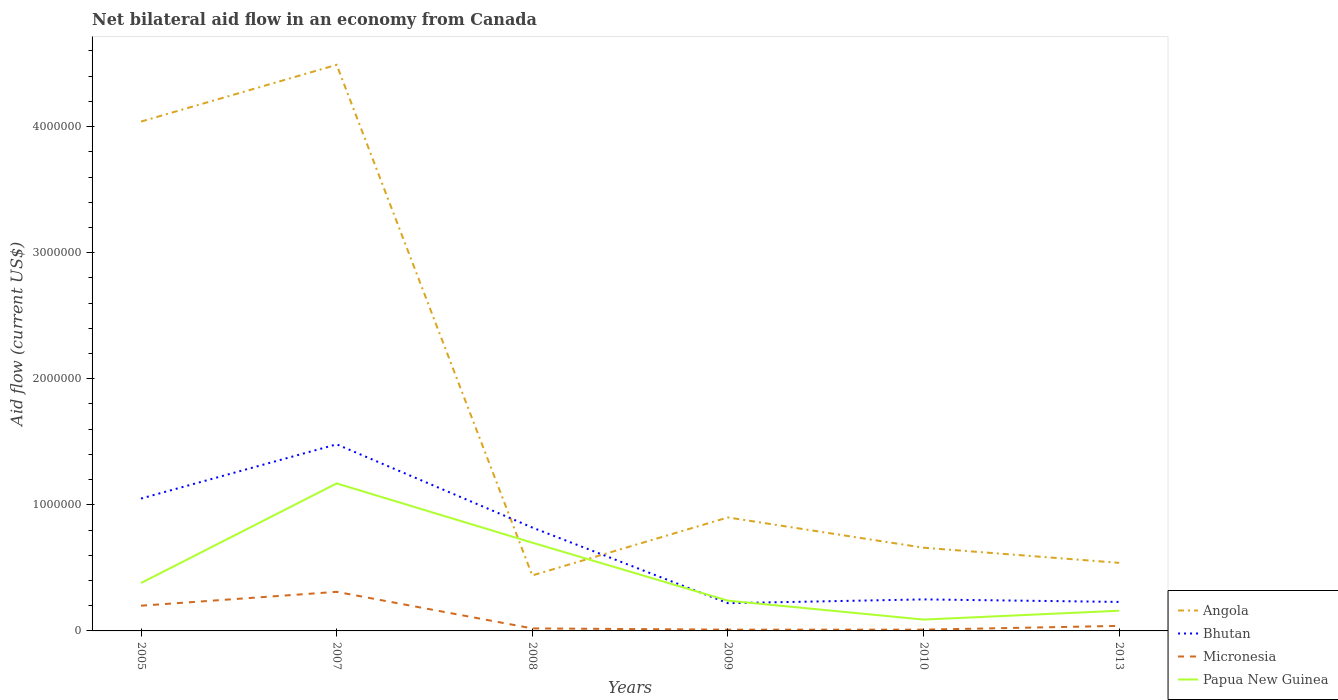In which year was the net bilateral aid flow in Angola maximum?
Your answer should be compact. 2008. What is the total net bilateral aid flow in Bhutan in the graph?
Ensure brevity in your answer.  5.70e+05. What is the difference between the highest and the second highest net bilateral aid flow in Micronesia?
Your response must be concise. 3.00e+05. What is the difference between two consecutive major ticks on the Y-axis?
Your response must be concise. 1.00e+06. Are the values on the major ticks of Y-axis written in scientific E-notation?
Give a very brief answer. No. How many legend labels are there?
Your answer should be very brief. 4. How are the legend labels stacked?
Make the answer very short. Vertical. What is the title of the graph?
Your answer should be compact. Net bilateral aid flow in an economy from Canada. What is the label or title of the Y-axis?
Your answer should be compact. Aid flow (current US$). What is the Aid flow (current US$) of Angola in 2005?
Offer a very short reply. 4.04e+06. What is the Aid flow (current US$) of Bhutan in 2005?
Offer a terse response. 1.05e+06. What is the Aid flow (current US$) in Micronesia in 2005?
Offer a terse response. 2.00e+05. What is the Aid flow (current US$) of Papua New Guinea in 2005?
Offer a terse response. 3.80e+05. What is the Aid flow (current US$) of Angola in 2007?
Make the answer very short. 4.49e+06. What is the Aid flow (current US$) of Bhutan in 2007?
Provide a succinct answer. 1.48e+06. What is the Aid flow (current US$) in Micronesia in 2007?
Offer a very short reply. 3.10e+05. What is the Aid flow (current US$) in Papua New Guinea in 2007?
Provide a short and direct response. 1.17e+06. What is the Aid flow (current US$) in Bhutan in 2008?
Your answer should be compact. 8.20e+05. What is the Aid flow (current US$) in Micronesia in 2008?
Your response must be concise. 2.00e+04. What is the Aid flow (current US$) in Bhutan in 2009?
Make the answer very short. 2.20e+05. What is the Aid flow (current US$) in Micronesia in 2009?
Make the answer very short. 10000. What is the Aid flow (current US$) of Bhutan in 2010?
Your answer should be compact. 2.50e+05. What is the Aid flow (current US$) of Micronesia in 2010?
Give a very brief answer. 10000. What is the Aid flow (current US$) of Papua New Guinea in 2010?
Ensure brevity in your answer.  9.00e+04. What is the Aid flow (current US$) of Angola in 2013?
Give a very brief answer. 5.40e+05. What is the Aid flow (current US$) of Micronesia in 2013?
Ensure brevity in your answer.  4.00e+04. Across all years, what is the maximum Aid flow (current US$) of Angola?
Give a very brief answer. 4.49e+06. Across all years, what is the maximum Aid flow (current US$) of Bhutan?
Provide a short and direct response. 1.48e+06. Across all years, what is the maximum Aid flow (current US$) of Micronesia?
Your response must be concise. 3.10e+05. Across all years, what is the maximum Aid flow (current US$) in Papua New Guinea?
Offer a very short reply. 1.17e+06. Across all years, what is the minimum Aid flow (current US$) of Bhutan?
Your answer should be compact. 2.20e+05. Across all years, what is the minimum Aid flow (current US$) in Micronesia?
Provide a succinct answer. 10000. What is the total Aid flow (current US$) of Angola in the graph?
Give a very brief answer. 1.11e+07. What is the total Aid flow (current US$) in Bhutan in the graph?
Provide a short and direct response. 4.05e+06. What is the total Aid flow (current US$) of Micronesia in the graph?
Give a very brief answer. 5.90e+05. What is the total Aid flow (current US$) in Papua New Guinea in the graph?
Provide a short and direct response. 2.74e+06. What is the difference between the Aid flow (current US$) in Angola in 2005 and that in 2007?
Your answer should be compact. -4.50e+05. What is the difference between the Aid flow (current US$) in Bhutan in 2005 and that in 2007?
Keep it short and to the point. -4.30e+05. What is the difference between the Aid flow (current US$) in Papua New Guinea in 2005 and that in 2007?
Make the answer very short. -7.90e+05. What is the difference between the Aid flow (current US$) in Angola in 2005 and that in 2008?
Your answer should be compact. 3.60e+06. What is the difference between the Aid flow (current US$) of Bhutan in 2005 and that in 2008?
Give a very brief answer. 2.30e+05. What is the difference between the Aid flow (current US$) in Papua New Guinea in 2005 and that in 2008?
Your answer should be very brief. -3.20e+05. What is the difference between the Aid flow (current US$) in Angola in 2005 and that in 2009?
Your answer should be compact. 3.14e+06. What is the difference between the Aid flow (current US$) in Bhutan in 2005 and that in 2009?
Offer a terse response. 8.30e+05. What is the difference between the Aid flow (current US$) in Micronesia in 2005 and that in 2009?
Keep it short and to the point. 1.90e+05. What is the difference between the Aid flow (current US$) in Angola in 2005 and that in 2010?
Keep it short and to the point. 3.38e+06. What is the difference between the Aid flow (current US$) of Bhutan in 2005 and that in 2010?
Make the answer very short. 8.00e+05. What is the difference between the Aid flow (current US$) of Papua New Guinea in 2005 and that in 2010?
Offer a terse response. 2.90e+05. What is the difference between the Aid flow (current US$) in Angola in 2005 and that in 2013?
Provide a succinct answer. 3.50e+06. What is the difference between the Aid flow (current US$) in Bhutan in 2005 and that in 2013?
Provide a succinct answer. 8.20e+05. What is the difference between the Aid flow (current US$) of Micronesia in 2005 and that in 2013?
Provide a short and direct response. 1.60e+05. What is the difference between the Aid flow (current US$) in Papua New Guinea in 2005 and that in 2013?
Your response must be concise. 2.20e+05. What is the difference between the Aid flow (current US$) in Angola in 2007 and that in 2008?
Your answer should be compact. 4.05e+06. What is the difference between the Aid flow (current US$) of Papua New Guinea in 2007 and that in 2008?
Offer a terse response. 4.70e+05. What is the difference between the Aid flow (current US$) in Angola in 2007 and that in 2009?
Your response must be concise. 3.59e+06. What is the difference between the Aid flow (current US$) in Bhutan in 2007 and that in 2009?
Offer a terse response. 1.26e+06. What is the difference between the Aid flow (current US$) in Micronesia in 2007 and that in 2009?
Give a very brief answer. 3.00e+05. What is the difference between the Aid flow (current US$) of Papua New Guinea in 2007 and that in 2009?
Provide a short and direct response. 9.30e+05. What is the difference between the Aid flow (current US$) in Angola in 2007 and that in 2010?
Offer a very short reply. 3.83e+06. What is the difference between the Aid flow (current US$) in Bhutan in 2007 and that in 2010?
Provide a short and direct response. 1.23e+06. What is the difference between the Aid flow (current US$) of Micronesia in 2007 and that in 2010?
Make the answer very short. 3.00e+05. What is the difference between the Aid flow (current US$) of Papua New Guinea in 2007 and that in 2010?
Your response must be concise. 1.08e+06. What is the difference between the Aid flow (current US$) in Angola in 2007 and that in 2013?
Keep it short and to the point. 3.95e+06. What is the difference between the Aid flow (current US$) in Bhutan in 2007 and that in 2013?
Make the answer very short. 1.25e+06. What is the difference between the Aid flow (current US$) in Micronesia in 2007 and that in 2013?
Provide a short and direct response. 2.70e+05. What is the difference between the Aid flow (current US$) of Papua New Guinea in 2007 and that in 2013?
Offer a terse response. 1.01e+06. What is the difference between the Aid flow (current US$) of Angola in 2008 and that in 2009?
Offer a very short reply. -4.60e+05. What is the difference between the Aid flow (current US$) in Papua New Guinea in 2008 and that in 2009?
Provide a short and direct response. 4.60e+05. What is the difference between the Aid flow (current US$) in Bhutan in 2008 and that in 2010?
Offer a terse response. 5.70e+05. What is the difference between the Aid flow (current US$) in Papua New Guinea in 2008 and that in 2010?
Provide a succinct answer. 6.10e+05. What is the difference between the Aid flow (current US$) in Bhutan in 2008 and that in 2013?
Keep it short and to the point. 5.90e+05. What is the difference between the Aid flow (current US$) of Micronesia in 2008 and that in 2013?
Offer a terse response. -2.00e+04. What is the difference between the Aid flow (current US$) in Papua New Guinea in 2008 and that in 2013?
Provide a succinct answer. 5.40e+05. What is the difference between the Aid flow (current US$) in Angola in 2009 and that in 2010?
Your answer should be compact. 2.40e+05. What is the difference between the Aid flow (current US$) of Micronesia in 2009 and that in 2010?
Provide a short and direct response. 0. What is the difference between the Aid flow (current US$) in Papua New Guinea in 2009 and that in 2010?
Ensure brevity in your answer.  1.50e+05. What is the difference between the Aid flow (current US$) in Angola in 2009 and that in 2013?
Your answer should be compact. 3.60e+05. What is the difference between the Aid flow (current US$) of Micronesia in 2009 and that in 2013?
Provide a short and direct response. -3.00e+04. What is the difference between the Aid flow (current US$) of Papua New Guinea in 2009 and that in 2013?
Your answer should be compact. 8.00e+04. What is the difference between the Aid flow (current US$) in Micronesia in 2010 and that in 2013?
Your answer should be compact. -3.00e+04. What is the difference between the Aid flow (current US$) in Papua New Guinea in 2010 and that in 2013?
Make the answer very short. -7.00e+04. What is the difference between the Aid flow (current US$) of Angola in 2005 and the Aid flow (current US$) of Bhutan in 2007?
Provide a succinct answer. 2.56e+06. What is the difference between the Aid flow (current US$) in Angola in 2005 and the Aid flow (current US$) in Micronesia in 2007?
Your response must be concise. 3.73e+06. What is the difference between the Aid flow (current US$) in Angola in 2005 and the Aid flow (current US$) in Papua New Guinea in 2007?
Your answer should be very brief. 2.87e+06. What is the difference between the Aid flow (current US$) of Bhutan in 2005 and the Aid flow (current US$) of Micronesia in 2007?
Keep it short and to the point. 7.40e+05. What is the difference between the Aid flow (current US$) in Micronesia in 2005 and the Aid flow (current US$) in Papua New Guinea in 2007?
Provide a short and direct response. -9.70e+05. What is the difference between the Aid flow (current US$) of Angola in 2005 and the Aid flow (current US$) of Bhutan in 2008?
Your response must be concise. 3.22e+06. What is the difference between the Aid flow (current US$) of Angola in 2005 and the Aid flow (current US$) of Micronesia in 2008?
Give a very brief answer. 4.02e+06. What is the difference between the Aid flow (current US$) of Angola in 2005 and the Aid flow (current US$) of Papua New Guinea in 2008?
Make the answer very short. 3.34e+06. What is the difference between the Aid flow (current US$) of Bhutan in 2005 and the Aid flow (current US$) of Micronesia in 2008?
Your response must be concise. 1.03e+06. What is the difference between the Aid flow (current US$) of Micronesia in 2005 and the Aid flow (current US$) of Papua New Guinea in 2008?
Give a very brief answer. -5.00e+05. What is the difference between the Aid flow (current US$) of Angola in 2005 and the Aid flow (current US$) of Bhutan in 2009?
Your response must be concise. 3.82e+06. What is the difference between the Aid flow (current US$) of Angola in 2005 and the Aid flow (current US$) of Micronesia in 2009?
Offer a very short reply. 4.03e+06. What is the difference between the Aid flow (current US$) in Angola in 2005 and the Aid flow (current US$) in Papua New Guinea in 2009?
Give a very brief answer. 3.80e+06. What is the difference between the Aid flow (current US$) of Bhutan in 2005 and the Aid flow (current US$) of Micronesia in 2009?
Your answer should be very brief. 1.04e+06. What is the difference between the Aid flow (current US$) of Bhutan in 2005 and the Aid flow (current US$) of Papua New Guinea in 2009?
Your response must be concise. 8.10e+05. What is the difference between the Aid flow (current US$) in Micronesia in 2005 and the Aid flow (current US$) in Papua New Guinea in 2009?
Keep it short and to the point. -4.00e+04. What is the difference between the Aid flow (current US$) in Angola in 2005 and the Aid flow (current US$) in Bhutan in 2010?
Keep it short and to the point. 3.79e+06. What is the difference between the Aid flow (current US$) in Angola in 2005 and the Aid flow (current US$) in Micronesia in 2010?
Provide a short and direct response. 4.03e+06. What is the difference between the Aid flow (current US$) of Angola in 2005 and the Aid flow (current US$) of Papua New Guinea in 2010?
Provide a short and direct response. 3.95e+06. What is the difference between the Aid flow (current US$) of Bhutan in 2005 and the Aid flow (current US$) of Micronesia in 2010?
Provide a succinct answer. 1.04e+06. What is the difference between the Aid flow (current US$) in Bhutan in 2005 and the Aid flow (current US$) in Papua New Guinea in 2010?
Your answer should be compact. 9.60e+05. What is the difference between the Aid flow (current US$) in Micronesia in 2005 and the Aid flow (current US$) in Papua New Guinea in 2010?
Keep it short and to the point. 1.10e+05. What is the difference between the Aid flow (current US$) in Angola in 2005 and the Aid flow (current US$) in Bhutan in 2013?
Give a very brief answer. 3.81e+06. What is the difference between the Aid flow (current US$) in Angola in 2005 and the Aid flow (current US$) in Micronesia in 2013?
Your response must be concise. 4.00e+06. What is the difference between the Aid flow (current US$) of Angola in 2005 and the Aid flow (current US$) of Papua New Guinea in 2013?
Give a very brief answer. 3.88e+06. What is the difference between the Aid flow (current US$) in Bhutan in 2005 and the Aid flow (current US$) in Micronesia in 2013?
Your answer should be very brief. 1.01e+06. What is the difference between the Aid flow (current US$) in Bhutan in 2005 and the Aid flow (current US$) in Papua New Guinea in 2013?
Your answer should be compact. 8.90e+05. What is the difference between the Aid flow (current US$) in Micronesia in 2005 and the Aid flow (current US$) in Papua New Guinea in 2013?
Your response must be concise. 4.00e+04. What is the difference between the Aid flow (current US$) in Angola in 2007 and the Aid flow (current US$) in Bhutan in 2008?
Provide a succinct answer. 3.67e+06. What is the difference between the Aid flow (current US$) of Angola in 2007 and the Aid flow (current US$) of Micronesia in 2008?
Your response must be concise. 4.47e+06. What is the difference between the Aid flow (current US$) in Angola in 2007 and the Aid flow (current US$) in Papua New Guinea in 2008?
Provide a short and direct response. 3.79e+06. What is the difference between the Aid flow (current US$) of Bhutan in 2007 and the Aid flow (current US$) of Micronesia in 2008?
Make the answer very short. 1.46e+06. What is the difference between the Aid flow (current US$) in Bhutan in 2007 and the Aid flow (current US$) in Papua New Guinea in 2008?
Provide a short and direct response. 7.80e+05. What is the difference between the Aid flow (current US$) of Micronesia in 2007 and the Aid flow (current US$) of Papua New Guinea in 2008?
Give a very brief answer. -3.90e+05. What is the difference between the Aid flow (current US$) in Angola in 2007 and the Aid flow (current US$) in Bhutan in 2009?
Offer a terse response. 4.27e+06. What is the difference between the Aid flow (current US$) in Angola in 2007 and the Aid flow (current US$) in Micronesia in 2009?
Offer a very short reply. 4.48e+06. What is the difference between the Aid flow (current US$) in Angola in 2007 and the Aid flow (current US$) in Papua New Guinea in 2009?
Keep it short and to the point. 4.25e+06. What is the difference between the Aid flow (current US$) in Bhutan in 2007 and the Aid flow (current US$) in Micronesia in 2009?
Provide a succinct answer. 1.47e+06. What is the difference between the Aid flow (current US$) in Bhutan in 2007 and the Aid flow (current US$) in Papua New Guinea in 2009?
Offer a very short reply. 1.24e+06. What is the difference between the Aid flow (current US$) in Angola in 2007 and the Aid flow (current US$) in Bhutan in 2010?
Provide a succinct answer. 4.24e+06. What is the difference between the Aid flow (current US$) of Angola in 2007 and the Aid flow (current US$) of Micronesia in 2010?
Ensure brevity in your answer.  4.48e+06. What is the difference between the Aid flow (current US$) in Angola in 2007 and the Aid flow (current US$) in Papua New Guinea in 2010?
Give a very brief answer. 4.40e+06. What is the difference between the Aid flow (current US$) in Bhutan in 2007 and the Aid flow (current US$) in Micronesia in 2010?
Your answer should be very brief. 1.47e+06. What is the difference between the Aid flow (current US$) in Bhutan in 2007 and the Aid flow (current US$) in Papua New Guinea in 2010?
Your response must be concise. 1.39e+06. What is the difference between the Aid flow (current US$) in Angola in 2007 and the Aid flow (current US$) in Bhutan in 2013?
Ensure brevity in your answer.  4.26e+06. What is the difference between the Aid flow (current US$) of Angola in 2007 and the Aid flow (current US$) of Micronesia in 2013?
Provide a succinct answer. 4.45e+06. What is the difference between the Aid flow (current US$) of Angola in 2007 and the Aid flow (current US$) of Papua New Guinea in 2013?
Provide a succinct answer. 4.33e+06. What is the difference between the Aid flow (current US$) in Bhutan in 2007 and the Aid flow (current US$) in Micronesia in 2013?
Offer a very short reply. 1.44e+06. What is the difference between the Aid flow (current US$) of Bhutan in 2007 and the Aid flow (current US$) of Papua New Guinea in 2013?
Make the answer very short. 1.32e+06. What is the difference between the Aid flow (current US$) in Angola in 2008 and the Aid flow (current US$) in Papua New Guinea in 2009?
Ensure brevity in your answer.  2.00e+05. What is the difference between the Aid flow (current US$) of Bhutan in 2008 and the Aid flow (current US$) of Micronesia in 2009?
Keep it short and to the point. 8.10e+05. What is the difference between the Aid flow (current US$) in Bhutan in 2008 and the Aid flow (current US$) in Papua New Guinea in 2009?
Make the answer very short. 5.80e+05. What is the difference between the Aid flow (current US$) in Micronesia in 2008 and the Aid flow (current US$) in Papua New Guinea in 2009?
Your response must be concise. -2.20e+05. What is the difference between the Aid flow (current US$) of Angola in 2008 and the Aid flow (current US$) of Bhutan in 2010?
Your answer should be very brief. 1.90e+05. What is the difference between the Aid flow (current US$) of Angola in 2008 and the Aid flow (current US$) of Micronesia in 2010?
Make the answer very short. 4.30e+05. What is the difference between the Aid flow (current US$) of Angola in 2008 and the Aid flow (current US$) of Papua New Guinea in 2010?
Provide a short and direct response. 3.50e+05. What is the difference between the Aid flow (current US$) in Bhutan in 2008 and the Aid flow (current US$) in Micronesia in 2010?
Offer a very short reply. 8.10e+05. What is the difference between the Aid flow (current US$) of Bhutan in 2008 and the Aid flow (current US$) of Papua New Guinea in 2010?
Your response must be concise. 7.30e+05. What is the difference between the Aid flow (current US$) of Angola in 2008 and the Aid flow (current US$) of Micronesia in 2013?
Keep it short and to the point. 4.00e+05. What is the difference between the Aid flow (current US$) in Bhutan in 2008 and the Aid flow (current US$) in Micronesia in 2013?
Give a very brief answer. 7.80e+05. What is the difference between the Aid flow (current US$) in Angola in 2009 and the Aid flow (current US$) in Bhutan in 2010?
Your answer should be very brief. 6.50e+05. What is the difference between the Aid flow (current US$) in Angola in 2009 and the Aid flow (current US$) in Micronesia in 2010?
Provide a short and direct response. 8.90e+05. What is the difference between the Aid flow (current US$) of Angola in 2009 and the Aid flow (current US$) of Papua New Guinea in 2010?
Keep it short and to the point. 8.10e+05. What is the difference between the Aid flow (current US$) in Micronesia in 2009 and the Aid flow (current US$) in Papua New Guinea in 2010?
Keep it short and to the point. -8.00e+04. What is the difference between the Aid flow (current US$) in Angola in 2009 and the Aid flow (current US$) in Bhutan in 2013?
Keep it short and to the point. 6.70e+05. What is the difference between the Aid flow (current US$) of Angola in 2009 and the Aid flow (current US$) of Micronesia in 2013?
Your answer should be compact. 8.60e+05. What is the difference between the Aid flow (current US$) of Angola in 2009 and the Aid flow (current US$) of Papua New Guinea in 2013?
Offer a terse response. 7.40e+05. What is the difference between the Aid flow (current US$) in Micronesia in 2009 and the Aid flow (current US$) in Papua New Guinea in 2013?
Your response must be concise. -1.50e+05. What is the difference between the Aid flow (current US$) of Angola in 2010 and the Aid flow (current US$) of Micronesia in 2013?
Your answer should be compact. 6.20e+05. What is the difference between the Aid flow (current US$) of Angola in 2010 and the Aid flow (current US$) of Papua New Guinea in 2013?
Give a very brief answer. 5.00e+05. What is the difference between the Aid flow (current US$) in Bhutan in 2010 and the Aid flow (current US$) in Micronesia in 2013?
Keep it short and to the point. 2.10e+05. What is the difference between the Aid flow (current US$) in Bhutan in 2010 and the Aid flow (current US$) in Papua New Guinea in 2013?
Make the answer very short. 9.00e+04. What is the difference between the Aid flow (current US$) in Micronesia in 2010 and the Aid flow (current US$) in Papua New Guinea in 2013?
Ensure brevity in your answer.  -1.50e+05. What is the average Aid flow (current US$) in Angola per year?
Your response must be concise. 1.84e+06. What is the average Aid flow (current US$) in Bhutan per year?
Make the answer very short. 6.75e+05. What is the average Aid flow (current US$) in Micronesia per year?
Offer a terse response. 9.83e+04. What is the average Aid flow (current US$) in Papua New Guinea per year?
Provide a succinct answer. 4.57e+05. In the year 2005, what is the difference between the Aid flow (current US$) of Angola and Aid flow (current US$) of Bhutan?
Your answer should be very brief. 2.99e+06. In the year 2005, what is the difference between the Aid flow (current US$) in Angola and Aid flow (current US$) in Micronesia?
Ensure brevity in your answer.  3.84e+06. In the year 2005, what is the difference between the Aid flow (current US$) of Angola and Aid flow (current US$) of Papua New Guinea?
Keep it short and to the point. 3.66e+06. In the year 2005, what is the difference between the Aid flow (current US$) in Bhutan and Aid flow (current US$) in Micronesia?
Your answer should be very brief. 8.50e+05. In the year 2005, what is the difference between the Aid flow (current US$) of Bhutan and Aid flow (current US$) of Papua New Guinea?
Offer a terse response. 6.70e+05. In the year 2007, what is the difference between the Aid flow (current US$) in Angola and Aid flow (current US$) in Bhutan?
Ensure brevity in your answer.  3.01e+06. In the year 2007, what is the difference between the Aid flow (current US$) in Angola and Aid flow (current US$) in Micronesia?
Offer a very short reply. 4.18e+06. In the year 2007, what is the difference between the Aid flow (current US$) of Angola and Aid flow (current US$) of Papua New Guinea?
Offer a terse response. 3.32e+06. In the year 2007, what is the difference between the Aid flow (current US$) of Bhutan and Aid flow (current US$) of Micronesia?
Your answer should be compact. 1.17e+06. In the year 2007, what is the difference between the Aid flow (current US$) in Micronesia and Aid flow (current US$) in Papua New Guinea?
Your response must be concise. -8.60e+05. In the year 2008, what is the difference between the Aid flow (current US$) in Angola and Aid flow (current US$) in Bhutan?
Provide a short and direct response. -3.80e+05. In the year 2008, what is the difference between the Aid flow (current US$) in Bhutan and Aid flow (current US$) in Papua New Guinea?
Make the answer very short. 1.20e+05. In the year 2008, what is the difference between the Aid flow (current US$) in Micronesia and Aid flow (current US$) in Papua New Guinea?
Ensure brevity in your answer.  -6.80e+05. In the year 2009, what is the difference between the Aid flow (current US$) in Angola and Aid flow (current US$) in Bhutan?
Ensure brevity in your answer.  6.80e+05. In the year 2009, what is the difference between the Aid flow (current US$) of Angola and Aid flow (current US$) of Micronesia?
Provide a short and direct response. 8.90e+05. In the year 2009, what is the difference between the Aid flow (current US$) in Bhutan and Aid flow (current US$) in Micronesia?
Ensure brevity in your answer.  2.10e+05. In the year 2009, what is the difference between the Aid flow (current US$) in Micronesia and Aid flow (current US$) in Papua New Guinea?
Provide a short and direct response. -2.30e+05. In the year 2010, what is the difference between the Aid flow (current US$) in Angola and Aid flow (current US$) in Bhutan?
Provide a succinct answer. 4.10e+05. In the year 2010, what is the difference between the Aid flow (current US$) of Angola and Aid flow (current US$) of Micronesia?
Offer a very short reply. 6.50e+05. In the year 2010, what is the difference between the Aid flow (current US$) of Angola and Aid flow (current US$) of Papua New Guinea?
Offer a very short reply. 5.70e+05. In the year 2010, what is the difference between the Aid flow (current US$) in Bhutan and Aid flow (current US$) in Micronesia?
Keep it short and to the point. 2.40e+05. In the year 2010, what is the difference between the Aid flow (current US$) of Micronesia and Aid flow (current US$) of Papua New Guinea?
Provide a succinct answer. -8.00e+04. In the year 2013, what is the difference between the Aid flow (current US$) in Angola and Aid flow (current US$) in Papua New Guinea?
Your answer should be compact. 3.80e+05. In the year 2013, what is the difference between the Aid flow (current US$) of Bhutan and Aid flow (current US$) of Papua New Guinea?
Give a very brief answer. 7.00e+04. In the year 2013, what is the difference between the Aid flow (current US$) of Micronesia and Aid flow (current US$) of Papua New Guinea?
Keep it short and to the point. -1.20e+05. What is the ratio of the Aid flow (current US$) in Angola in 2005 to that in 2007?
Provide a short and direct response. 0.9. What is the ratio of the Aid flow (current US$) of Bhutan in 2005 to that in 2007?
Your answer should be compact. 0.71. What is the ratio of the Aid flow (current US$) of Micronesia in 2005 to that in 2007?
Offer a terse response. 0.65. What is the ratio of the Aid flow (current US$) of Papua New Guinea in 2005 to that in 2007?
Your answer should be compact. 0.32. What is the ratio of the Aid flow (current US$) of Angola in 2005 to that in 2008?
Give a very brief answer. 9.18. What is the ratio of the Aid flow (current US$) in Bhutan in 2005 to that in 2008?
Your answer should be very brief. 1.28. What is the ratio of the Aid flow (current US$) of Micronesia in 2005 to that in 2008?
Offer a terse response. 10. What is the ratio of the Aid flow (current US$) in Papua New Guinea in 2005 to that in 2008?
Offer a terse response. 0.54. What is the ratio of the Aid flow (current US$) of Angola in 2005 to that in 2009?
Offer a terse response. 4.49. What is the ratio of the Aid flow (current US$) in Bhutan in 2005 to that in 2009?
Offer a very short reply. 4.77. What is the ratio of the Aid flow (current US$) of Micronesia in 2005 to that in 2009?
Make the answer very short. 20. What is the ratio of the Aid flow (current US$) of Papua New Guinea in 2005 to that in 2009?
Offer a terse response. 1.58. What is the ratio of the Aid flow (current US$) in Angola in 2005 to that in 2010?
Provide a succinct answer. 6.12. What is the ratio of the Aid flow (current US$) of Micronesia in 2005 to that in 2010?
Provide a short and direct response. 20. What is the ratio of the Aid flow (current US$) of Papua New Guinea in 2005 to that in 2010?
Ensure brevity in your answer.  4.22. What is the ratio of the Aid flow (current US$) in Angola in 2005 to that in 2013?
Offer a very short reply. 7.48. What is the ratio of the Aid flow (current US$) in Bhutan in 2005 to that in 2013?
Your response must be concise. 4.57. What is the ratio of the Aid flow (current US$) of Papua New Guinea in 2005 to that in 2013?
Provide a succinct answer. 2.38. What is the ratio of the Aid flow (current US$) in Angola in 2007 to that in 2008?
Your answer should be very brief. 10.2. What is the ratio of the Aid flow (current US$) of Bhutan in 2007 to that in 2008?
Keep it short and to the point. 1.8. What is the ratio of the Aid flow (current US$) in Papua New Guinea in 2007 to that in 2008?
Provide a succinct answer. 1.67. What is the ratio of the Aid flow (current US$) of Angola in 2007 to that in 2009?
Provide a short and direct response. 4.99. What is the ratio of the Aid flow (current US$) in Bhutan in 2007 to that in 2009?
Your answer should be compact. 6.73. What is the ratio of the Aid flow (current US$) in Micronesia in 2007 to that in 2009?
Your answer should be very brief. 31. What is the ratio of the Aid flow (current US$) in Papua New Guinea in 2007 to that in 2009?
Give a very brief answer. 4.88. What is the ratio of the Aid flow (current US$) of Angola in 2007 to that in 2010?
Your answer should be very brief. 6.8. What is the ratio of the Aid flow (current US$) of Bhutan in 2007 to that in 2010?
Your response must be concise. 5.92. What is the ratio of the Aid flow (current US$) in Angola in 2007 to that in 2013?
Offer a terse response. 8.31. What is the ratio of the Aid flow (current US$) of Bhutan in 2007 to that in 2013?
Your answer should be compact. 6.43. What is the ratio of the Aid flow (current US$) of Micronesia in 2007 to that in 2013?
Make the answer very short. 7.75. What is the ratio of the Aid flow (current US$) in Papua New Guinea in 2007 to that in 2013?
Provide a short and direct response. 7.31. What is the ratio of the Aid flow (current US$) in Angola in 2008 to that in 2009?
Provide a short and direct response. 0.49. What is the ratio of the Aid flow (current US$) in Bhutan in 2008 to that in 2009?
Give a very brief answer. 3.73. What is the ratio of the Aid flow (current US$) in Papua New Guinea in 2008 to that in 2009?
Make the answer very short. 2.92. What is the ratio of the Aid flow (current US$) of Bhutan in 2008 to that in 2010?
Keep it short and to the point. 3.28. What is the ratio of the Aid flow (current US$) in Micronesia in 2008 to that in 2010?
Provide a short and direct response. 2. What is the ratio of the Aid flow (current US$) of Papua New Guinea in 2008 to that in 2010?
Keep it short and to the point. 7.78. What is the ratio of the Aid flow (current US$) in Angola in 2008 to that in 2013?
Make the answer very short. 0.81. What is the ratio of the Aid flow (current US$) of Bhutan in 2008 to that in 2013?
Offer a terse response. 3.57. What is the ratio of the Aid flow (current US$) of Papua New Guinea in 2008 to that in 2013?
Your response must be concise. 4.38. What is the ratio of the Aid flow (current US$) in Angola in 2009 to that in 2010?
Ensure brevity in your answer.  1.36. What is the ratio of the Aid flow (current US$) in Papua New Guinea in 2009 to that in 2010?
Keep it short and to the point. 2.67. What is the ratio of the Aid flow (current US$) of Bhutan in 2009 to that in 2013?
Your answer should be compact. 0.96. What is the ratio of the Aid flow (current US$) of Angola in 2010 to that in 2013?
Your response must be concise. 1.22. What is the ratio of the Aid flow (current US$) of Bhutan in 2010 to that in 2013?
Offer a terse response. 1.09. What is the ratio of the Aid flow (current US$) in Micronesia in 2010 to that in 2013?
Provide a succinct answer. 0.25. What is the ratio of the Aid flow (current US$) of Papua New Guinea in 2010 to that in 2013?
Offer a very short reply. 0.56. What is the difference between the highest and the second highest Aid flow (current US$) of Angola?
Your answer should be compact. 4.50e+05. What is the difference between the highest and the second highest Aid flow (current US$) in Bhutan?
Provide a short and direct response. 4.30e+05. What is the difference between the highest and the second highest Aid flow (current US$) in Papua New Guinea?
Keep it short and to the point. 4.70e+05. What is the difference between the highest and the lowest Aid flow (current US$) in Angola?
Keep it short and to the point. 4.05e+06. What is the difference between the highest and the lowest Aid flow (current US$) in Bhutan?
Provide a succinct answer. 1.26e+06. What is the difference between the highest and the lowest Aid flow (current US$) in Papua New Guinea?
Make the answer very short. 1.08e+06. 